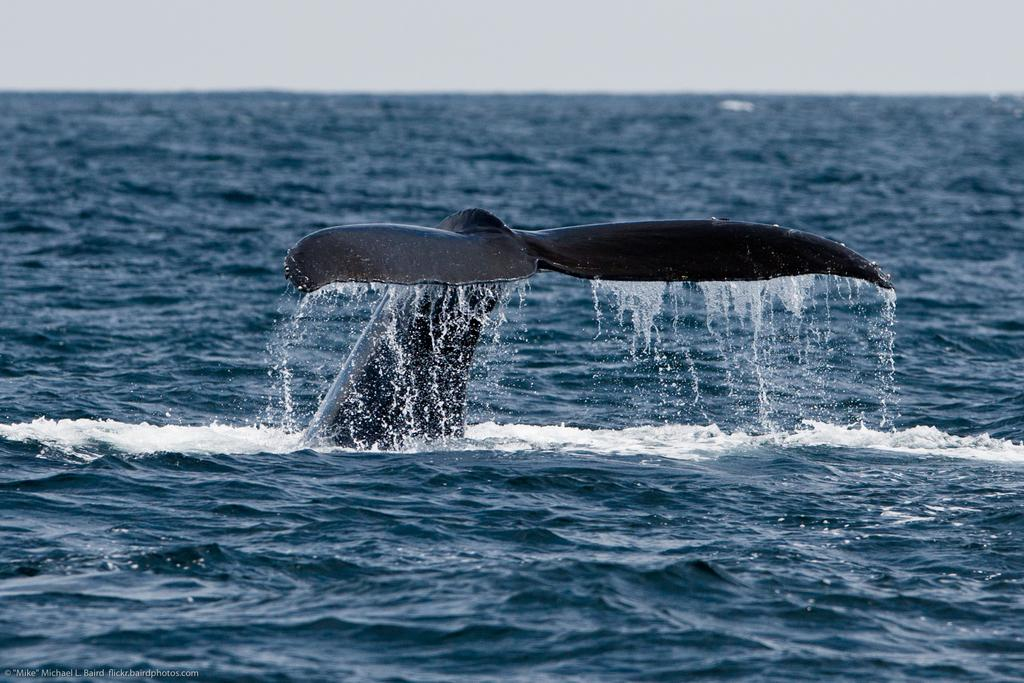What is the main subject in the center of the image? There is a fish tail in the center of the image. What is present at the bottom of the image? There is water at the bottom of the image. What type of room can be seen in the image? There is no room present in the image; it features a fish tail and water. How does the earth appear in the image? The image does not depict the earth; it focuses on a fish tail and water. 